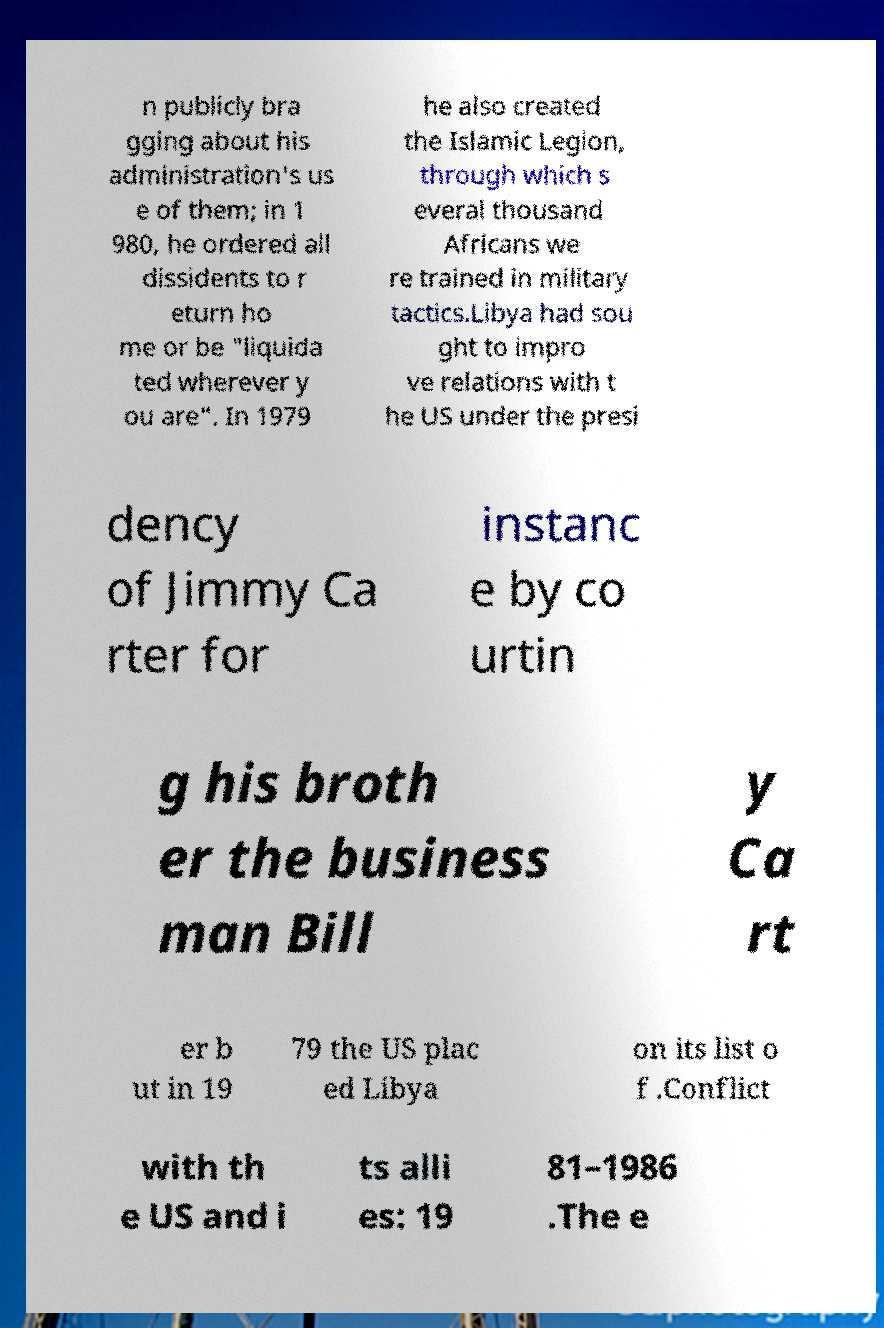Could you assist in decoding the text presented in this image and type it out clearly? n publicly bra gging about his administration's us e of them; in 1 980, he ordered all dissidents to r eturn ho me or be "liquida ted wherever y ou are". In 1979 he also created the Islamic Legion, through which s everal thousand Africans we re trained in military tactics.Libya had sou ght to impro ve relations with t he US under the presi dency of Jimmy Ca rter for instanc e by co urtin g his broth er the business man Bill y Ca rt er b ut in 19 79 the US plac ed Libya on its list o f .Conflict with th e US and i ts alli es: 19 81–1986 .The e 